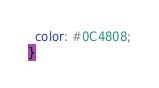Convert code to text. <code><loc_0><loc_0><loc_500><loc_500><_CSS_>  color: #0C4808;
}
</code> 